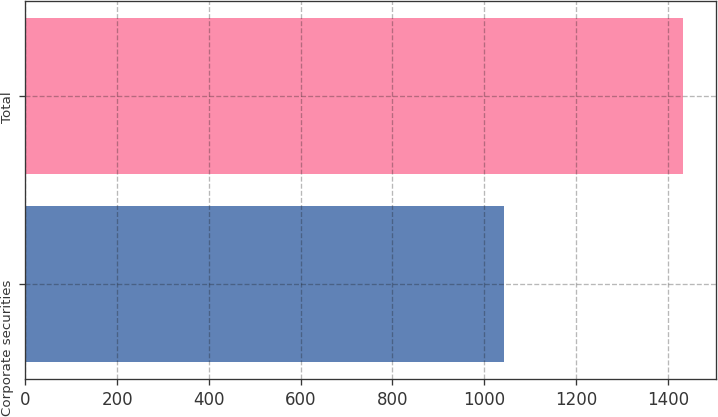<chart> <loc_0><loc_0><loc_500><loc_500><bar_chart><fcel>Corporate securities<fcel>Total<nl><fcel>1044<fcel>1433<nl></chart> 